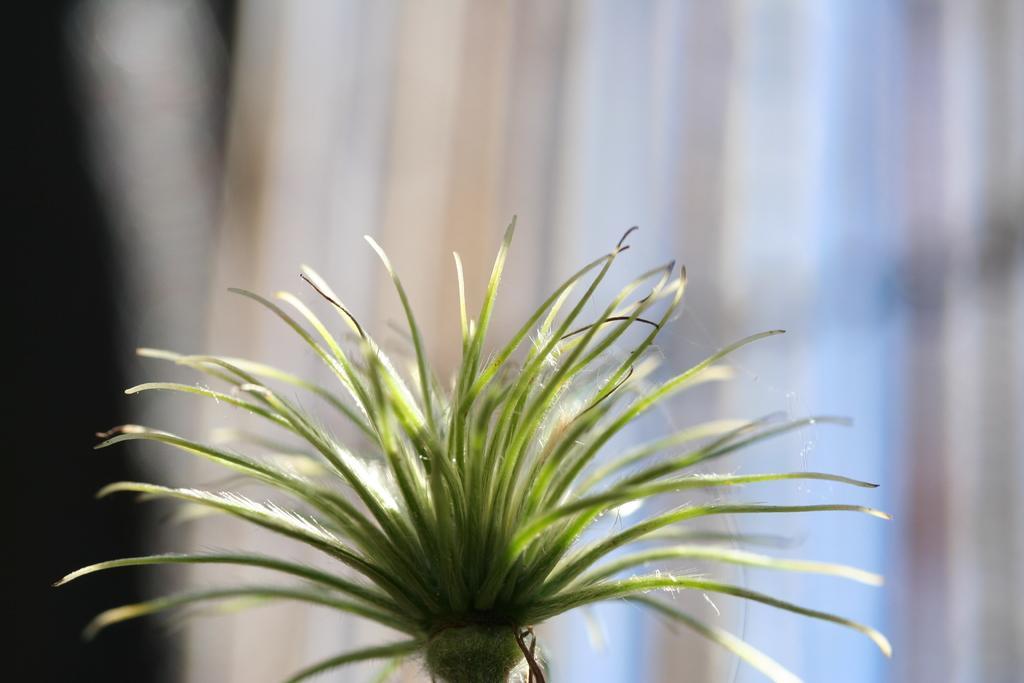Please provide a concise description of this image. In this picture we can see a plant, we can see a blurry background here. 